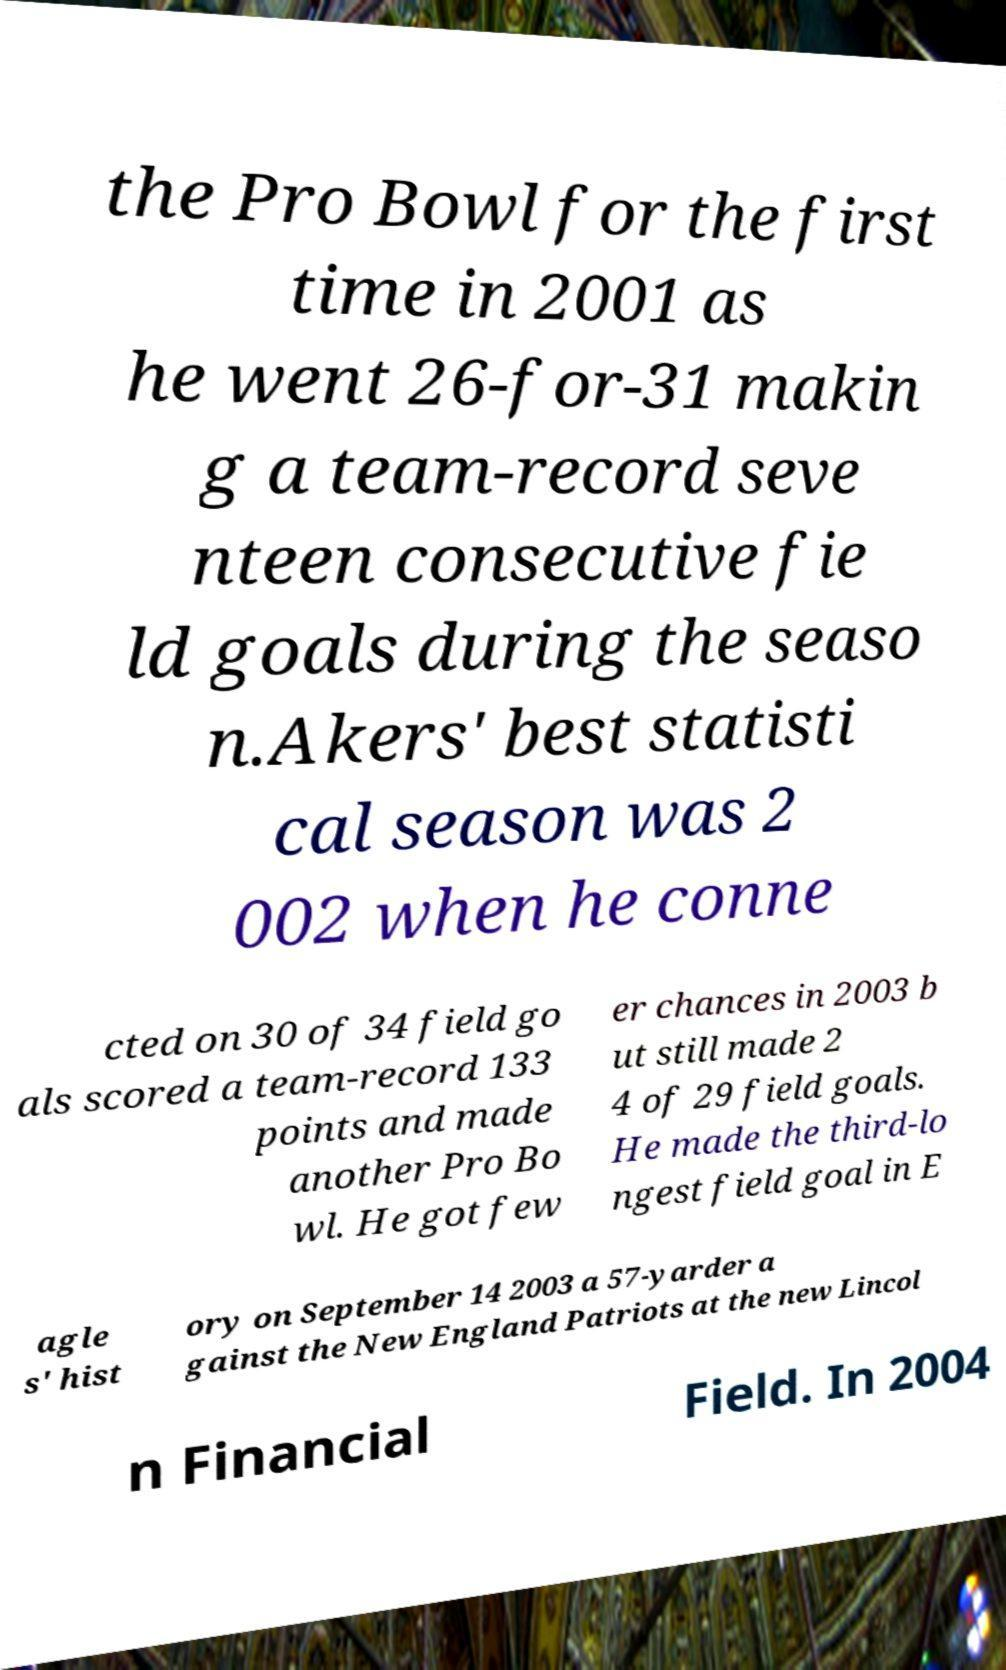What messages or text are displayed in this image? I need them in a readable, typed format. the Pro Bowl for the first time in 2001 as he went 26-for-31 makin g a team-record seve nteen consecutive fie ld goals during the seaso n.Akers' best statisti cal season was 2 002 when he conne cted on 30 of 34 field go als scored a team-record 133 points and made another Pro Bo wl. He got few er chances in 2003 b ut still made 2 4 of 29 field goals. He made the third-lo ngest field goal in E agle s' hist ory on September 14 2003 a 57-yarder a gainst the New England Patriots at the new Lincol n Financial Field. In 2004 